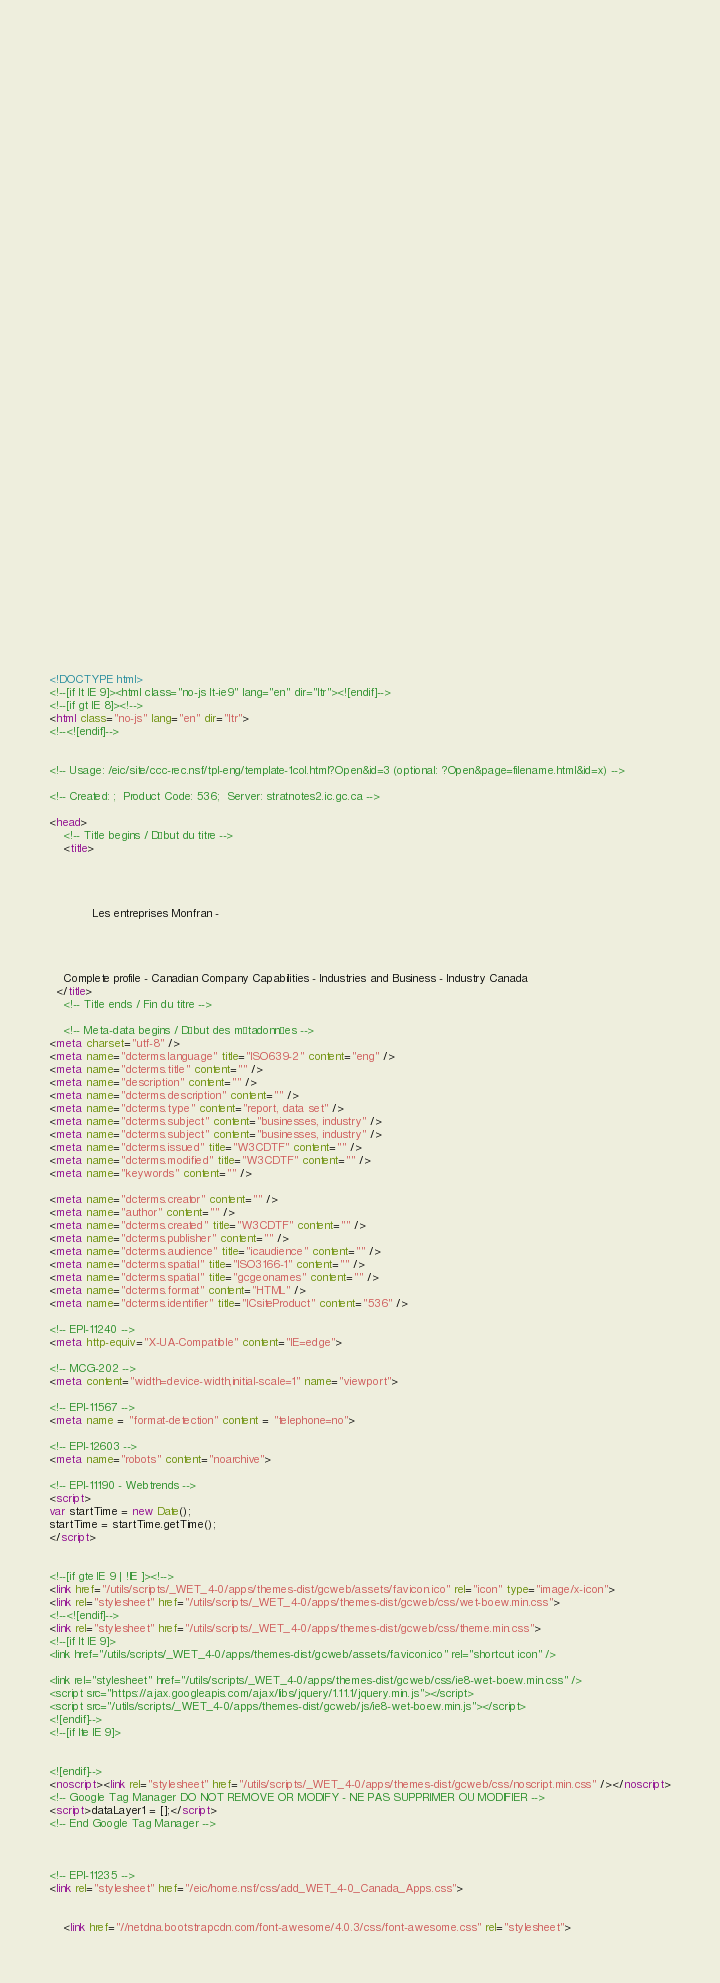<code> <loc_0><loc_0><loc_500><loc_500><_HTML_>


















	






  
  
  
  































	
	
	



<!DOCTYPE html>
<!--[if lt IE 9]><html class="no-js lt-ie9" lang="en" dir="ltr"><![endif]-->
<!--[if gt IE 8]><!-->
<html class="no-js" lang="en" dir="ltr">
<!--<![endif]-->


<!-- Usage: /eic/site/ccc-rec.nsf/tpl-eng/template-1col.html?Open&id=3 (optional: ?Open&page=filename.html&id=x) -->

<!-- Created: ;  Product Code: 536;  Server: stratnotes2.ic.gc.ca -->

<head>
	<!-- Title begins / Début du titre -->
	<title>
    
            
        
          
            Les entreprises Monfran -
          
        
      
    
    Complete profile - Canadian Company Capabilities - Industries and Business - Industry Canada
  </title>
	<!-- Title ends / Fin du titre -->
 
	<!-- Meta-data begins / Début des métadonnées -->
<meta charset="utf-8" />
<meta name="dcterms.language" title="ISO639-2" content="eng" />
<meta name="dcterms.title" content="" />
<meta name="description" content="" />
<meta name="dcterms.description" content="" />
<meta name="dcterms.type" content="report, data set" />
<meta name="dcterms.subject" content="businesses, industry" />
<meta name="dcterms.subject" content="businesses, industry" />
<meta name="dcterms.issued" title="W3CDTF" content="" />
<meta name="dcterms.modified" title="W3CDTF" content="" />
<meta name="keywords" content="" />

<meta name="dcterms.creator" content="" />
<meta name="author" content="" />
<meta name="dcterms.created" title="W3CDTF" content="" />
<meta name="dcterms.publisher" content="" />
<meta name="dcterms.audience" title="icaudience" content="" />
<meta name="dcterms.spatial" title="ISO3166-1" content="" />
<meta name="dcterms.spatial" title="gcgeonames" content="" />
<meta name="dcterms.format" content="HTML" />
<meta name="dcterms.identifier" title="ICsiteProduct" content="536" />

<!-- EPI-11240 -->
<meta http-equiv="X-UA-Compatible" content="IE=edge">

<!-- MCG-202 -->
<meta content="width=device-width,initial-scale=1" name="viewport">

<!-- EPI-11567 -->
<meta name = "format-detection" content = "telephone=no">

<!-- EPI-12603 -->
<meta name="robots" content="noarchive">

<!-- EPI-11190 - Webtrends -->
<script>
var startTime = new Date();
startTime = startTime.getTime();
</script>


<!--[if gte IE 9 | !IE ]><!-->
<link href="/utils/scripts/_WET_4-0/apps/themes-dist/gcweb/assets/favicon.ico" rel="icon" type="image/x-icon">
<link rel="stylesheet" href="/utils/scripts/_WET_4-0/apps/themes-dist/gcweb/css/wet-boew.min.css">
<!--<![endif]-->
<link rel="stylesheet" href="/utils/scripts/_WET_4-0/apps/themes-dist/gcweb/css/theme.min.css">
<!--[if lt IE 9]>
<link href="/utils/scripts/_WET_4-0/apps/themes-dist/gcweb/assets/favicon.ico" rel="shortcut icon" />

<link rel="stylesheet" href="/utils/scripts/_WET_4-0/apps/themes-dist/gcweb/css/ie8-wet-boew.min.css" />
<script src="https://ajax.googleapis.com/ajax/libs/jquery/1.11.1/jquery.min.js"></script>
<script src="/utils/scripts/_WET_4-0/apps/themes-dist/gcweb/js/ie8-wet-boew.min.js"></script>
<![endif]-->
<!--[if lte IE 9]>


<![endif]-->
<noscript><link rel="stylesheet" href="/utils/scripts/_WET_4-0/apps/themes-dist/gcweb/css/noscript.min.css" /></noscript>
<!-- Google Tag Manager DO NOT REMOVE OR MODIFY - NE PAS SUPPRIMER OU MODIFIER -->
<script>dataLayer1 = [];</script>
<!-- End Google Tag Manager -->



<!-- EPI-11235 -->
<link rel="stylesheet" href="/eic/home.nsf/css/add_WET_4-0_Canada_Apps.css">


  	<link href="//netdna.bootstrapcdn.com/font-awesome/4.0.3/css/font-awesome.css" rel="stylesheet"></code> 